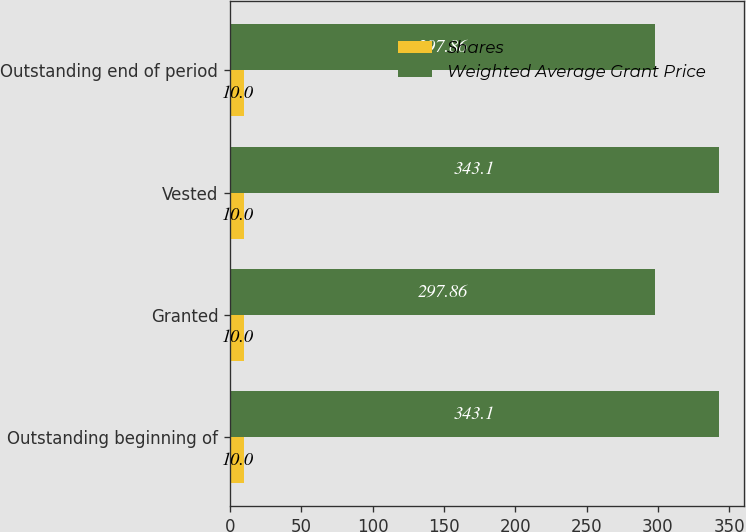Convert chart to OTSL. <chart><loc_0><loc_0><loc_500><loc_500><stacked_bar_chart><ecel><fcel>Outstanding beginning of<fcel>Granted<fcel>Vested<fcel>Outstanding end of period<nl><fcel>Shares<fcel>10<fcel>10<fcel>10<fcel>10<nl><fcel>Weighted Average Grant Price<fcel>343.1<fcel>297.86<fcel>343.1<fcel>297.86<nl></chart> 